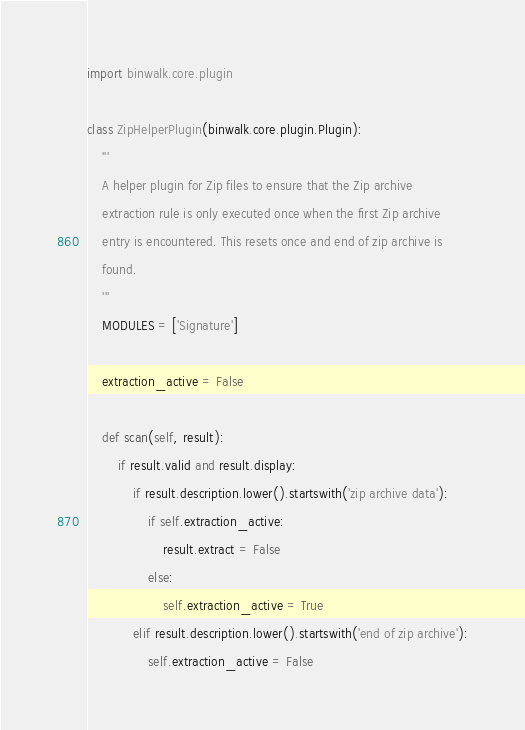Convert code to text. <code><loc_0><loc_0><loc_500><loc_500><_Python_>import binwalk.core.plugin

class ZipHelperPlugin(binwalk.core.plugin.Plugin):
    '''
    A helper plugin for Zip files to ensure that the Zip archive
    extraction rule is only executed once when the first Zip archive
    entry is encountered. This resets once and end of zip archive is
    found.
    '''
    MODULES = ['Signature']

    extraction_active = False

    def scan(self, result):
        if result.valid and result.display:
            if result.description.lower().startswith('zip archive data'):
                if self.extraction_active:
                    result.extract = False
                else:
                    self.extraction_active = True
            elif result.description.lower().startswith('end of zip archive'):
                self.extraction_active = False
</code> 